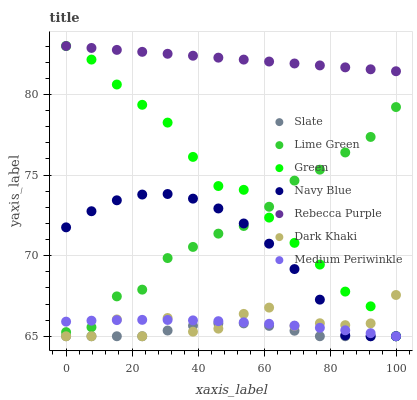Does Slate have the minimum area under the curve?
Answer yes or no. Yes. Does Rebecca Purple have the maximum area under the curve?
Answer yes or no. Yes. Does Medium Periwinkle have the minimum area under the curve?
Answer yes or no. No. Does Medium Periwinkle have the maximum area under the curve?
Answer yes or no. No. Is Rebecca Purple the smoothest?
Answer yes or no. Yes. Is Dark Khaki the roughest?
Answer yes or no. Yes. Is Slate the smoothest?
Answer yes or no. No. Is Slate the roughest?
Answer yes or no. No. Does Navy Blue have the lowest value?
Answer yes or no. Yes. Does Rebecca Purple have the lowest value?
Answer yes or no. No. Does Rebecca Purple have the highest value?
Answer yes or no. Yes. Does Medium Periwinkle have the highest value?
Answer yes or no. No. Is Dark Khaki less than Lime Green?
Answer yes or no. Yes. Is Rebecca Purple greater than Slate?
Answer yes or no. Yes. Does Navy Blue intersect Medium Periwinkle?
Answer yes or no. Yes. Is Navy Blue less than Medium Periwinkle?
Answer yes or no. No. Is Navy Blue greater than Medium Periwinkle?
Answer yes or no. No. Does Dark Khaki intersect Lime Green?
Answer yes or no. No. 